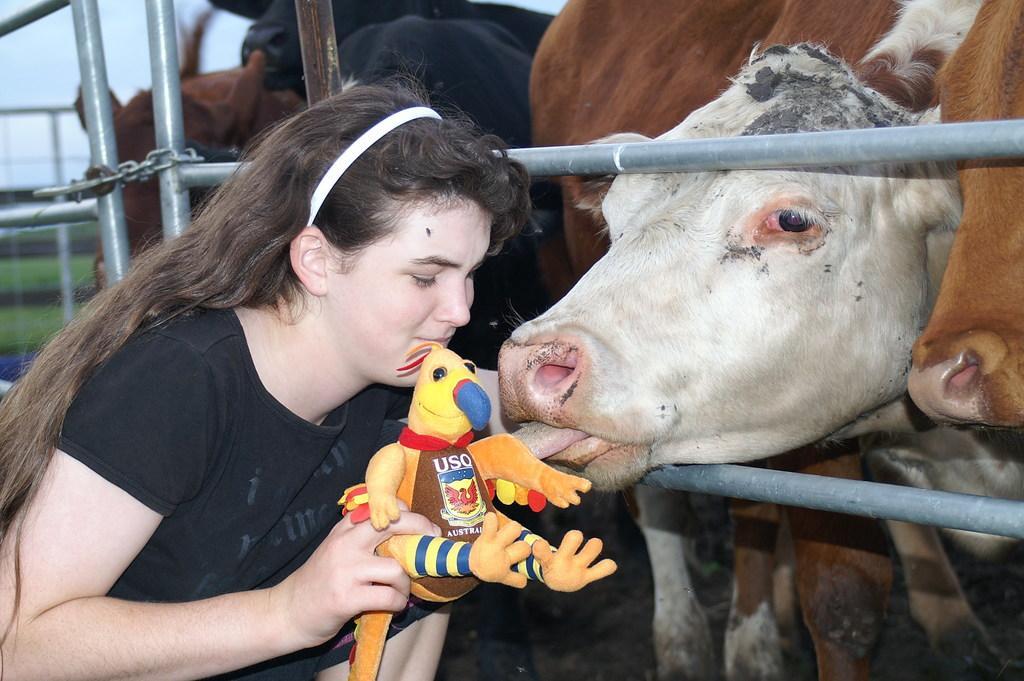Describe this image in one or two sentences. In this image I can see animals and a woman. The woman is holding some object in hands. The woman is wearing a black color T-shirt. Here I can see fence and a chain. 